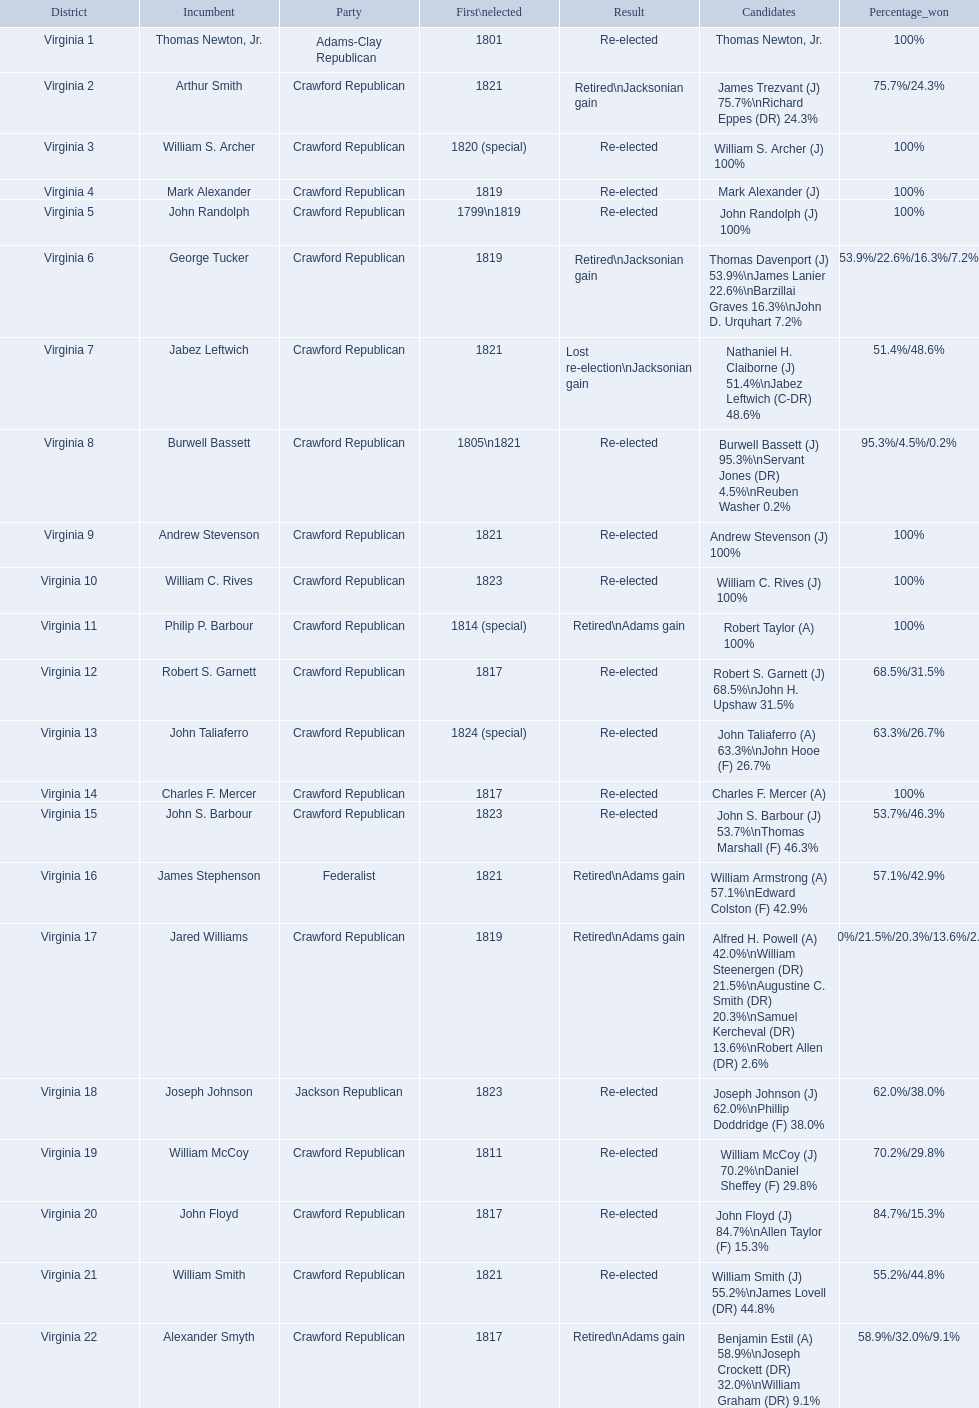Which incumbents belonged to the crawford republican party? Arthur Smith, William S. Archer, Mark Alexander, John Randolph, George Tucker, Jabez Leftwich, Burwell Bassett, Andrew Stevenson, William C. Rives, Philip P. Barbour, Robert S. Garnett, John Taliaferro, Charles F. Mercer, John S. Barbour, Jared Williams, William McCoy, John Floyd, William Smith, Alexander Smyth. Which of these incumbents were first elected in 1821? Arthur Smith, Jabez Leftwich, Andrew Stevenson, William Smith. Which of these incumbents have a last name of smith? Arthur Smith, William Smith. Which of these two were not re-elected? Arthur Smith. 